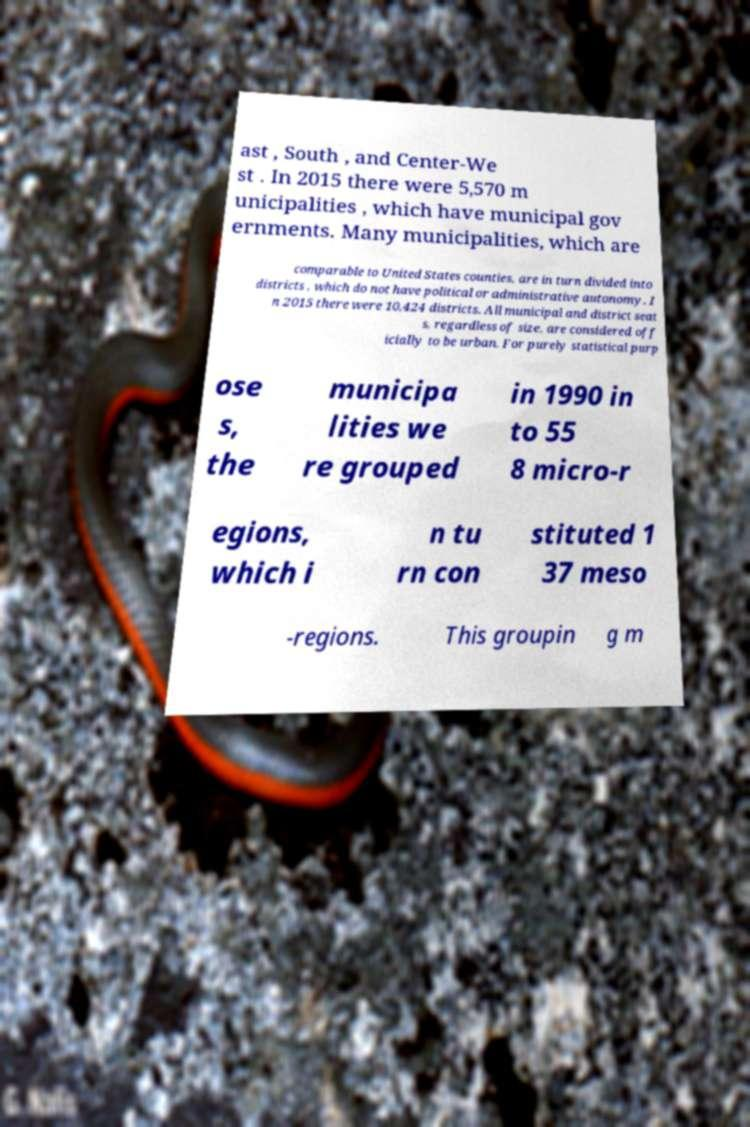Please identify and transcribe the text found in this image. ast , South , and Center-We st . In 2015 there were 5,570 m unicipalities , which have municipal gov ernments. Many municipalities, which are comparable to United States counties, are in turn divided into districts , which do not have political or administrative autonomy. I n 2015 there were 10,424 districts. All municipal and district seat s, regardless of size, are considered off icially to be urban. For purely statistical purp ose s, the municipa lities we re grouped in 1990 in to 55 8 micro-r egions, which i n tu rn con stituted 1 37 meso -regions. This groupin g m 